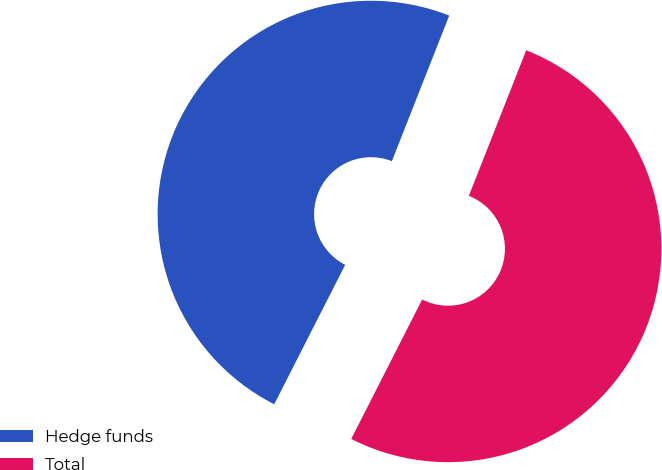Convert chart to OTSL. <chart><loc_0><loc_0><loc_500><loc_500><pie_chart><fcel>Hedge funds<fcel>Total<nl><fcel>48.48%<fcel>51.52%<nl></chart> 